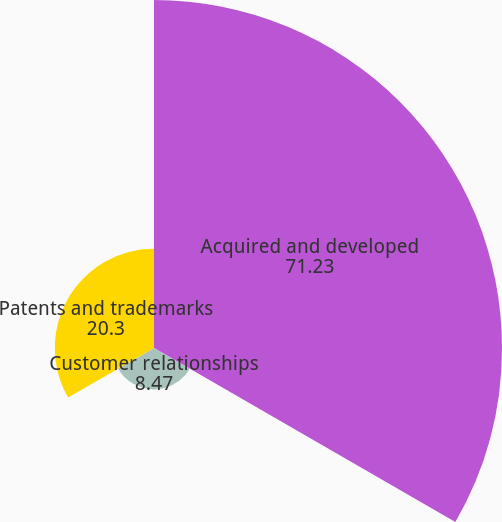Convert chart. <chart><loc_0><loc_0><loc_500><loc_500><pie_chart><fcel>Acquired and developed<fcel>Customer relationships<fcel>Patents and trademarks<nl><fcel>71.23%<fcel>8.47%<fcel>20.3%<nl></chart> 